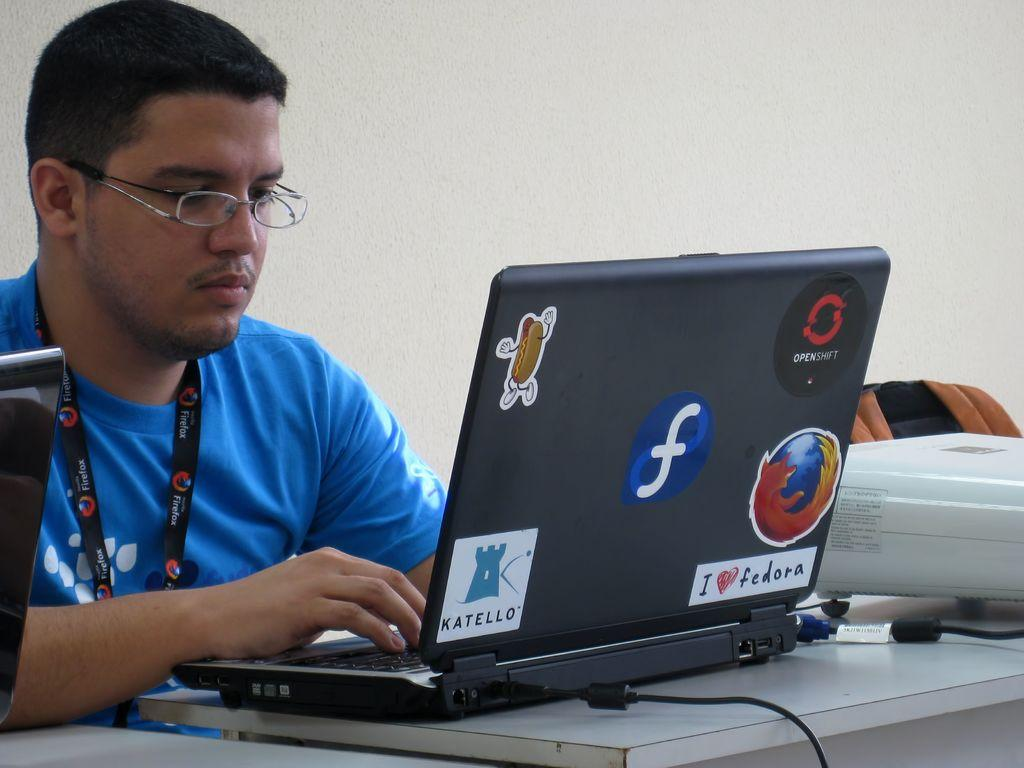Provide a one-sentence caption for the provided image. A man is using a laptop with a sticker that says Katello. 